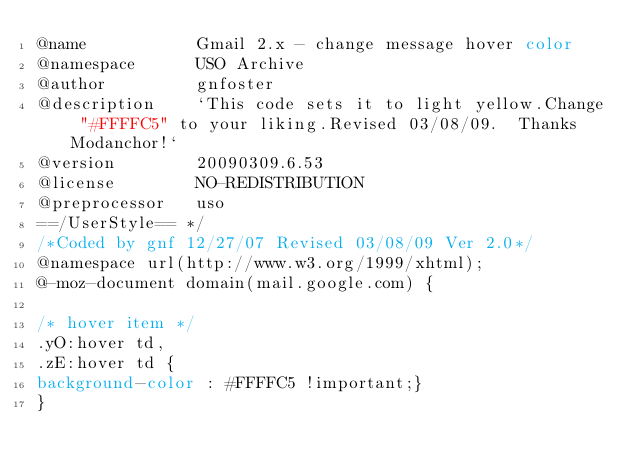Convert code to text. <code><loc_0><loc_0><loc_500><loc_500><_CSS_>@name           Gmail 2.x - change message hover color
@namespace      USO Archive
@author         gnfoster
@description    `This code sets it to light yellow.Change "#FFFFC5" to your liking.Revised 03/08/09.  Thanks Modanchor!`
@version        20090309.6.53
@license        NO-REDISTRIBUTION
@preprocessor   uso
==/UserStyle== */
/*Coded by gnf 12/27/07 Revised 03/08/09 Ver 2.0*/
@namespace url(http://www.w3.org/1999/xhtml);
@-moz-document domain(mail.google.com) {

/* hover item */
.yO:hover td,
.zE:hover td {
background-color : #FFFFC5 !important;}
}</code> 